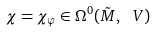<formula> <loc_0><loc_0><loc_500><loc_500>\chi = \chi _ { \varphi } \in \Omega ^ { 0 } ( \tilde { M } , \ V )</formula> 